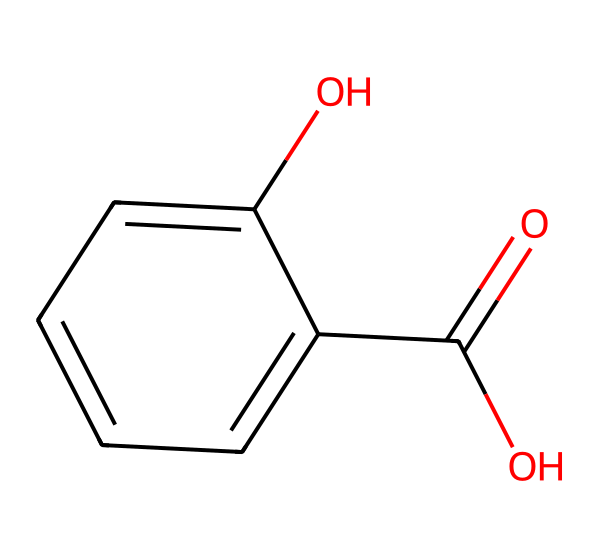What is the name of this chemical? The SMILES representation indicates a chemical structure that contains a hydroxyl group (-OH) and a carboxylic acid group (-COOH), which is characteristic of salicylic acid.
Answer: salicylic acid How many carbon atoms are in this molecule? By analyzing the SMILES representation, the structure shows there are seven carbon atoms, as counted in the cyclic and chain formations.
Answer: 7 What type of acid is salicylic acid classified as? The presence of the carboxylic acid functional group (-COOH) within the structure reveals that salicylic acid is classified as a weak organic acid.
Answer: organic Does this compound have any functional groups? Yes, the chemical structure contains two functional groups: a hydroxyl group (-OH) and a carboxylic acid group (-COOH).
Answer: Yes How many rings does this chemical structure contain? The structure depicted in the SMILES shows a single six-membered aromatic ring, confirming that there is one ring present in the molecule.
Answer: 1 What is the primary use of salicylic acid in topical creams? Salicylic acid is primarily used for its anti-inflammatory and pain-relieving properties, making it beneficial for treating muscle and joint pain in topical formulations.
Answer: pain relief 